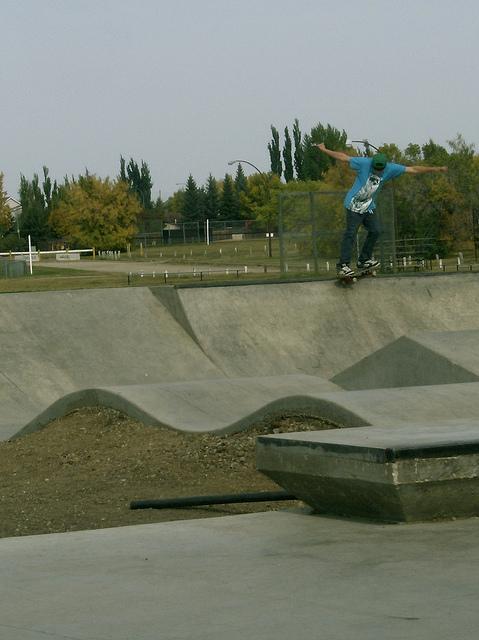Which sport is this?
Be succinct. Skateboarding. Are there many people in the background?
Write a very short answer. No. What is the man riding his skateboard on?
Write a very short answer. Ramp. Can you see people?
Short answer required. Yes. Is the skater's jacket plaid?
Write a very short answer. No. How many trees are in the picture?
Write a very short answer. 10. What are they skating on?
Write a very short answer. Ramp. Is the sky cloudless?
Give a very brief answer. Yes. Is the guy about to go down?
Write a very short answer. Yes. What is the man doing?
Short answer required. Skateboarding. How many people total can you see?
Concise answer only. 1. What structure is shown?
Write a very short answer. Skatepark. Is it a sunny day?
Answer briefly. No. What type of court is this?
Be succinct. Skateboard. 